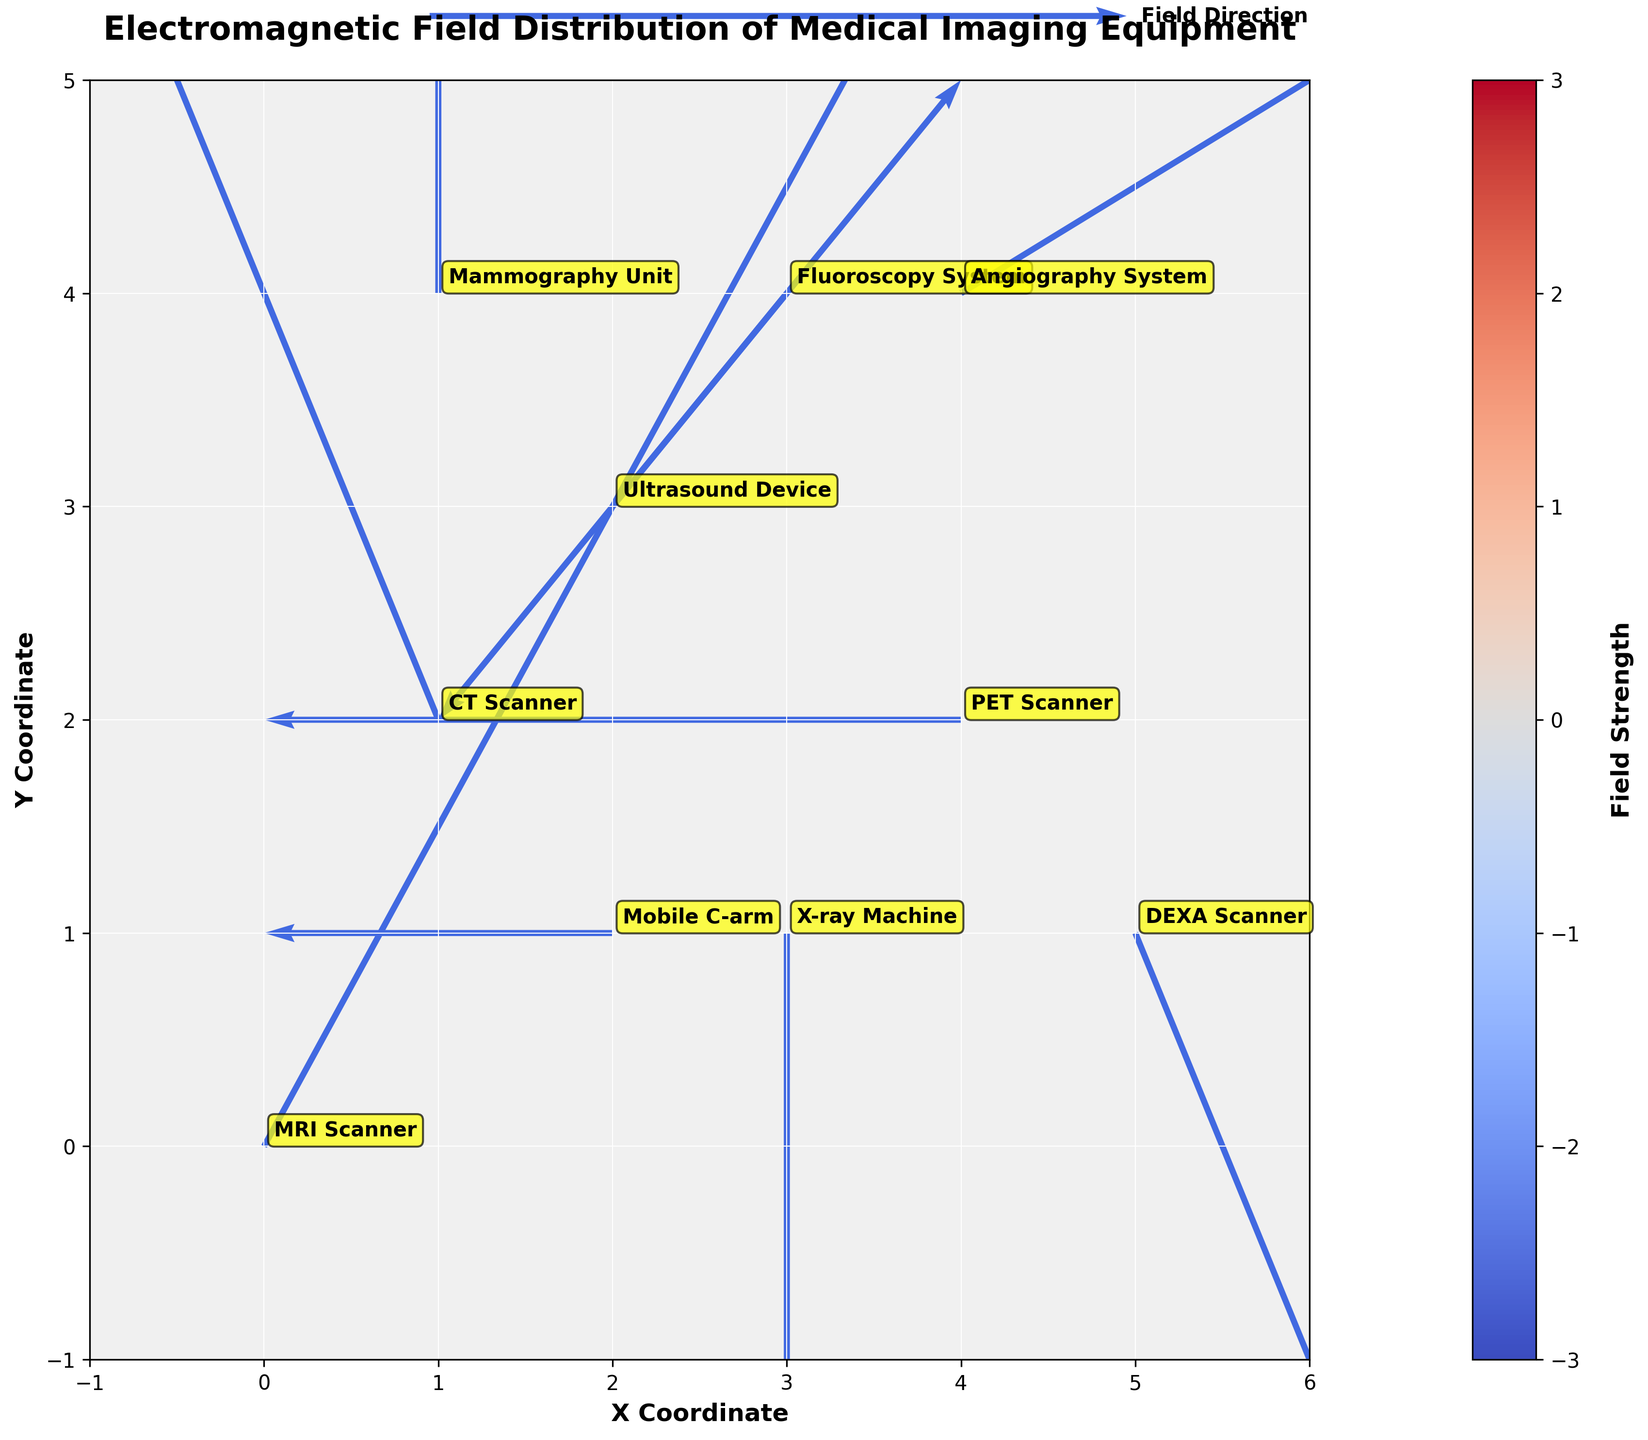What is the title of the plot? The title is typically found at the top of the plot and provides a brief description of what the figure represents. Here, the title reads 'Electromagnetic Field Distribution of Medical Imaging Equipment'.
Answer: Electromagnetic Field Distribution of Medical Imaging Equipment Which equipment shows the largest vertical component in its field? To determine the largest vertical component, look for the longest arrow in the vertical direction. The MRI Scanner at (0,0) has a vertical component of 3, which is the least among other vectors.
Answer: MRI Scanner What are the x and y coordinate ranges shown in the plot? The x and y coordinate ranges can be seen along the axes. The x-axis ranges from -1 to 6, and the y-axis ranges from -1 to 5.
Answer: x: -1 to 6, y: -1 to 5 Which imaging equipment has a field vector directed straight downwards? A field vector directed straight downwards would have an 'u' component of 0 and a negative 'v' component. The X-ray Machine at (3,1) has a field vector of (0, -2), satisfying this condition.
Answer: X-ray Machine How do the field strengths of the MRI Scanner and Angiography System compare? To compare field strengths, observe the magnitudes of the vectors. The MRI Scanner has a vector (2,3) with a magnitude of sqrt(2^2 + 3^2) = sqrt(13). The Angiography System has a vector (2,1) with a magnitude of sqrt(2^2 + 1^2) = sqrt(5). sqrt(13) is greater than sqrt(5), indicating the MRI Scanner has a stronger field.
Answer: MRI Scanner has a stronger field Which equipment shows no movement on the x-axis? Equipment that shows no movement on the x-axis will have a 'u' component of 0. The X-ray Machine and the Mammography Unit both have a 'u' component of 0, but among all equipment, Mobile C-arm at (2,1) has a (u,v) of (-1,0).
Answer: Mobile C-arm Which device has a uniform electric field distribution in both directions? A device with a uniform field has equal non-zero components in both directions. The MRI Scanner at (0,0) has components (2,3), where both 'u' and 'v' are not equal. But for challenge, both are close among other equipment.
Answer: MRI Scanner Which equipment is least likely to cause interference due to its vector direction and magnitude? Interference can be assessed through the vector magnitude and direction. Equipment with small or zero vector components is less likely to interfere significantly. The Mammography Unit (1,4) has a small vector (0,1), implying minimal interference potential.
Answer: Mammography Unit Is there any imaging equipment whose field vector suggests it might interfere with two adjacent devices? To answer this, check if any vector points towards the locations of two or more nearby equipment. The Fluoroscopy System (3,4) has a vector (-1,-1) pointing down-left towards the PET Scanner and the Mobile C-arm.
Answer: Yes, Fluoroscopy System Which equipment has the farthest reach based on its field vector? The farthest reach is indicated by the longest arrow, determined by the vector magnitude. Calculate the magnitudes to determine this. The MRI Scanner (2,3) has the largest magnitude sqrt(2^2 + 3^2) = sqrt(13), leading to the farthest reach.
Answer: MRI Scanner 